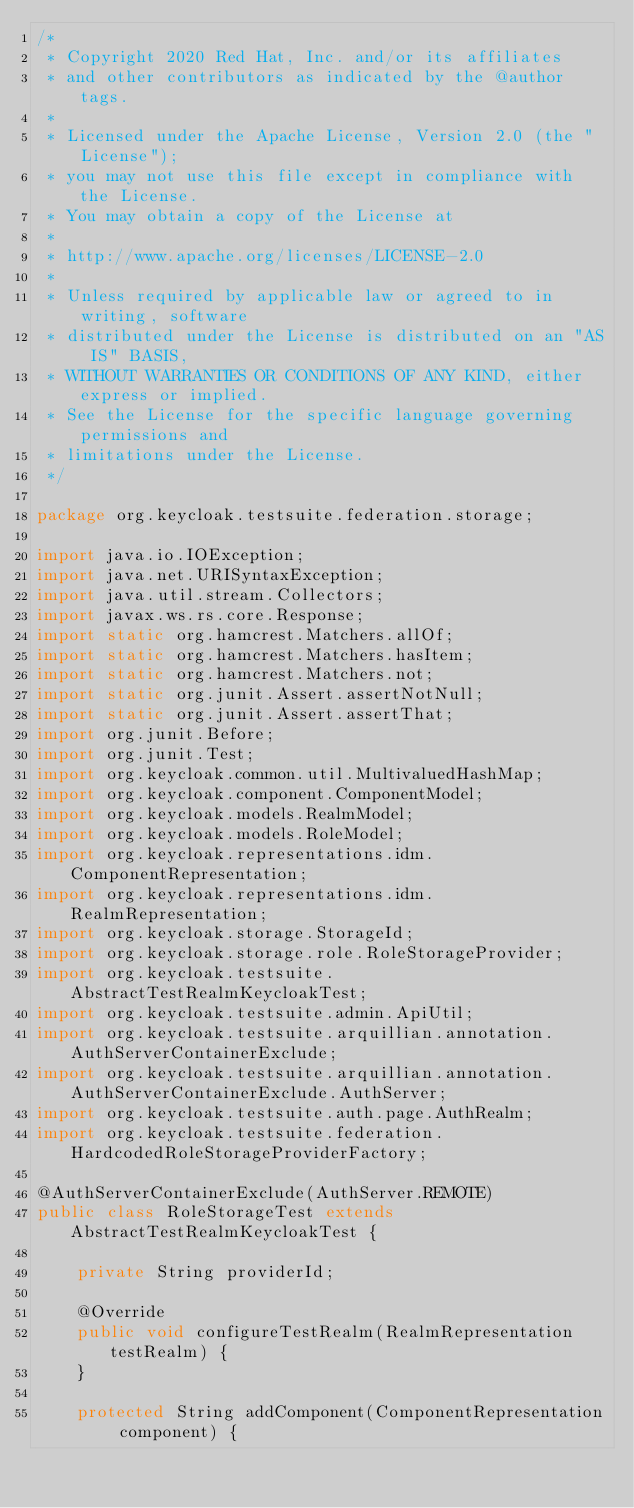Convert code to text. <code><loc_0><loc_0><loc_500><loc_500><_Java_>/*
 * Copyright 2020 Red Hat, Inc. and/or its affiliates
 * and other contributors as indicated by the @author tags.
 *
 * Licensed under the Apache License, Version 2.0 (the "License");
 * you may not use this file except in compliance with the License.
 * You may obtain a copy of the License at
 *
 * http://www.apache.org/licenses/LICENSE-2.0
 *
 * Unless required by applicable law or agreed to in writing, software
 * distributed under the License is distributed on an "AS IS" BASIS,
 * WITHOUT WARRANTIES OR CONDITIONS OF ANY KIND, either express or implied.
 * See the License for the specific language governing permissions and
 * limitations under the License.
 */

package org.keycloak.testsuite.federation.storage;

import java.io.IOException;
import java.net.URISyntaxException;
import java.util.stream.Collectors;
import javax.ws.rs.core.Response;
import static org.hamcrest.Matchers.allOf;
import static org.hamcrest.Matchers.hasItem;
import static org.hamcrest.Matchers.not;
import static org.junit.Assert.assertNotNull;
import static org.junit.Assert.assertThat;
import org.junit.Before;
import org.junit.Test;
import org.keycloak.common.util.MultivaluedHashMap;
import org.keycloak.component.ComponentModel;
import org.keycloak.models.RealmModel;
import org.keycloak.models.RoleModel;
import org.keycloak.representations.idm.ComponentRepresentation;
import org.keycloak.representations.idm.RealmRepresentation;
import org.keycloak.storage.StorageId;
import org.keycloak.storage.role.RoleStorageProvider;
import org.keycloak.testsuite.AbstractTestRealmKeycloakTest;
import org.keycloak.testsuite.admin.ApiUtil;
import org.keycloak.testsuite.arquillian.annotation.AuthServerContainerExclude;
import org.keycloak.testsuite.arquillian.annotation.AuthServerContainerExclude.AuthServer;
import org.keycloak.testsuite.auth.page.AuthRealm;
import org.keycloak.testsuite.federation.HardcodedRoleStorageProviderFactory;

@AuthServerContainerExclude(AuthServer.REMOTE)
public class RoleStorageTest extends AbstractTestRealmKeycloakTest {

    private String providerId;

    @Override
    public void configureTestRealm(RealmRepresentation testRealm) {
    }

    protected String addComponent(ComponentRepresentation component) {</code> 